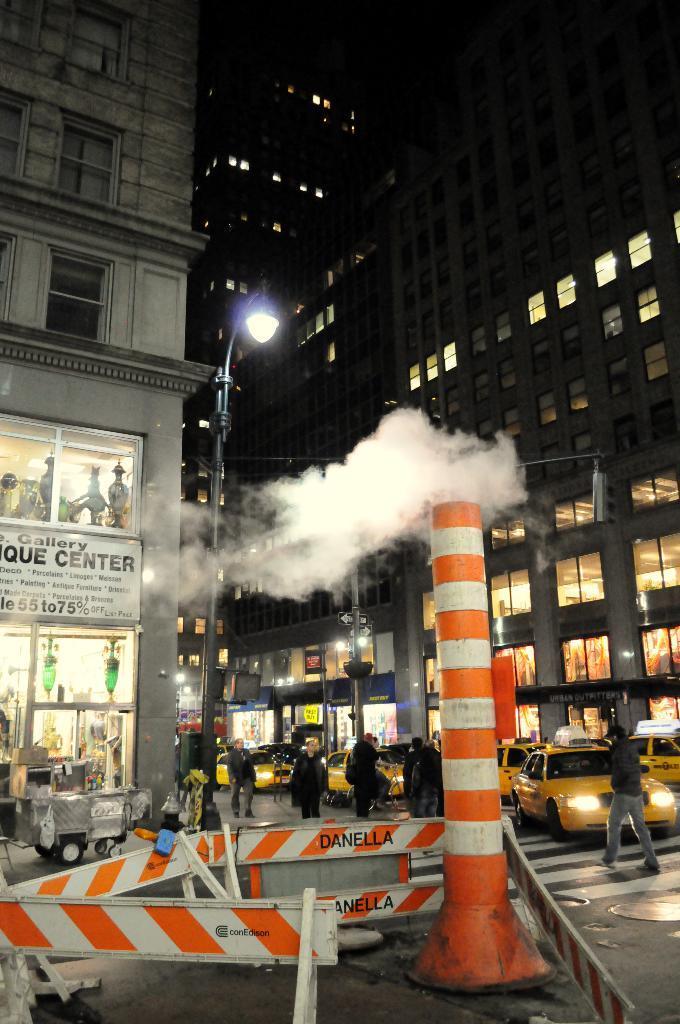Can you describe this image briefly? There are vehicles and persons on the road. Here we can see poles, lights, boards, and smoke. In the background there are buildings. 